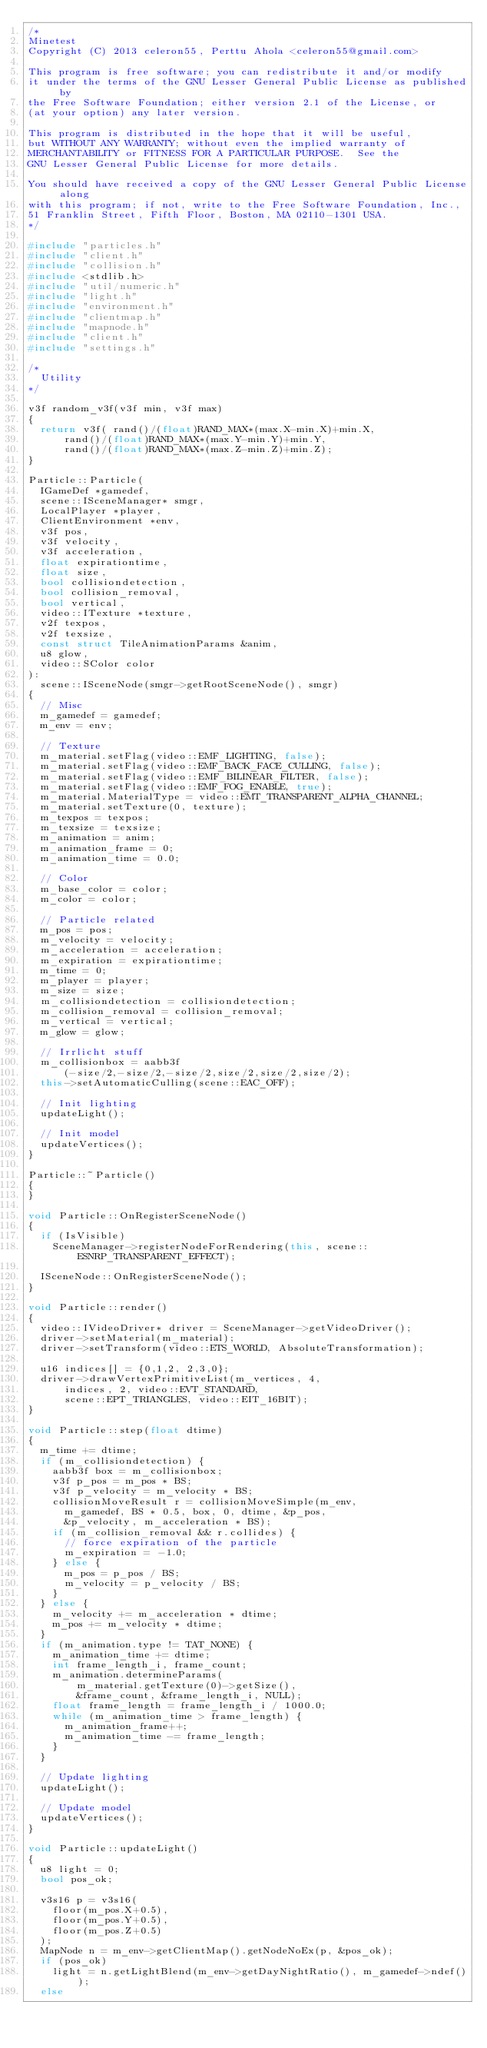Convert code to text. <code><loc_0><loc_0><loc_500><loc_500><_C++_>/*
Minetest
Copyright (C) 2013 celeron55, Perttu Ahola <celeron55@gmail.com>

This program is free software; you can redistribute it and/or modify
it under the terms of the GNU Lesser General Public License as published by
the Free Software Foundation; either version 2.1 of the License, or
(at your option) any later version.

This program is distributed in the hope that it will be useful,
but WITHOUT ANY WARRANTY; without even the implied warranty of
MERCHANTABILITY or FITNESS FOR A PARTICULAR PURPOSE.  See the
GNU Lesser General Public License for more details.

You should have received a copy of the GNU Lesser General Public License along
with this program; if not, write to the Free Software Foundation, Inc.,
51 Franklin Street, Fifth Floor, Boston, MA 02110-1301 USA.
*/

#include "particles.h"
#include "client.h"
#include "collision.h"
#include <stdlib.h>
#include "util/numeric.h"
#include "light.h"
#include "environment.h"
#include "clientmap.h"
#include "mapnode.h"
#include "client.h"
#include "settings.h"

/*
	Utility
*/

v3f random_v3f(v3f min, v3f max)
{
	return v3f( rand()/(float)RAND_MAX*(max.X-min.X)+min.X,
			rand()/(float)RAND_MAX*(max.Y-min.Y)+min.Y,
			rand()/(float)RAND_MAX*(max.Z-min.Z)+min.Z);
}

Particle::Particle(
	IGameDef *gamedef,
	scene::ISceneManager* smgr,
	LocalPlayer *player,
	ClientEnvironment *env,
	v3f pos,
	v3f velocity,
	v3f acceleration,
	float expirationtime,
	float size,
	bool collisiondetection,
	bool collision_removal,
	bool vertical,
	video::ITexture *texture,
	v2f texpos,
	v2f texsize,
	const struct TileAnimationParams &anim,
	u8 glow,
	video::SColor color
):
	scene::ISceneNode(smgr->getRootSceneNode(), smgr)
{
	// Misc
	m_gamedef = gamedef;
	m_env = env;

	// Texture
	m_material.setFlag(video::EMF_LIGHTING, false);
	m_material.setFlag(video::EMF_BACK_FACE_CULLING, false);
	m_material.setFlag(video::EMF_BILINEAR_FILTER, false);
	m_material.setFlag(video::EMF_FOG_ENABLE, true);
	m_material.MaterialType = video::EMT_TRANSPARENT_ALPHA_CHANNEL;
	m_material.setTexture(0, texture);
	m_texpos = texpos;
	m_texsize = texsize;
	m_animation = anim;
	m_animation_frame = 0;
	m_animation_time = 0.0;

	// Color
	m_base_color = color;
	m_color = color;

	// Particle related
	m_pos = pos;
	m_velocity = velocity;
	m_acceleration = acceleration;
	m_expiration = expirationtime;
	m_time = 0;
	m_player = player;
	m_size = size;
	m_collisiondetection = collisiondetection;
	m_collision_removal = collision_removal;
	m_vertical = vertical;
	m_glow = glow;

	// Irrlicht stuff
	m_collisionbox = aabb3f
			(-size/2,-size/2,-size/2,size/2,size/2,size/2);
	this->setAutomaticCulling(scene::EAC_OFF);

	// Init lighting
	updateLight();

	// Init model
	updateVertices();
}

Particle::~Particle()
{
}

void Particle::OnRegisterSceneNode()
{
	if (IsVisible)
		SceneManager->registerNodeForRendering(this, scene::ESNRP_TRANSPARENT_EFFECT);

	ISceneNode::OnRegisterSceneNode();
}

void Particle::render()
{
	video::IVideoDriver* driver = SceneManager->getVideoDriver();
	driver->setMaterial(m_material);
	driver->setTransform(video::ETS_WORLD, AbsoluteTransformation);

	u16 indices[] = {0,1,2, 2,3,0};
	driver->drawVertexPrimitiveList(m_vertices, 4,
			indices, 2, video::EVT_STANDARD,
			scene::EPT_TRIANGLES, video::EIT_16BIT);
}

void Particle::step(float dtime)
{
	m_time += dtime;
	if (m_collisiondetection) {
		aabb3f box = m_collisionbox;
		v3f p_pos = m_pos * BS;
		v3f p_velocity = m_velocity * BS;
		collisionMoveResult r = collisionMoveSimple(m_env,
			m_gamedef, BS * 0.5, box, 0, dtime, &p_pos,
			&p_velocity, m_acceleration * BS);
		if (m_collision_removal && r.collides) {
			// force expiration of the particle
			m_expiration = -1.0;
		} else {
			m_pos = p_pos / BS;
			m_velocity = p_velocity / BS;
		}
	} else {
		m_velocity += m_acceleration * dtime;
		m_pos += m_velocity * dtime;
	}
	if (m_animation.type != TAT_NONE) {
		m_animation_time += dtime;
		int frame_length_i, frame_count;
		m_animation.determineParams(
				m_material.getTexture(0)->getSize(),
				&frame_count, &frame_length_i, NULL);
		float frame_length = frame_length_i / 1000.0;
		while (m_animation_time > frame_length) {
			m_animation_frame++;
			m_animation_time -= frame_length;
		}
	}

	// Update lighting
	updateLight();

	// Update model
	updateVertices();
}

void Particle::updateLight()
{
	u8 light = 0;
	bool pos_ok;

	v3s16 p = v3s16(
		floor(m_pos.X+0.5),
		floor(m_pos.Y+0.5),
		floor(m_pos.Z+0.5)
	);
	MapNode n = m_env->getClientMap().getNodeNoEx(p, &pos_ok);
	if (pos_ok)
		light = n.getLightBlend(m_env->getDayNightRatio(), m_gamedef->ndef());
	else</code> 